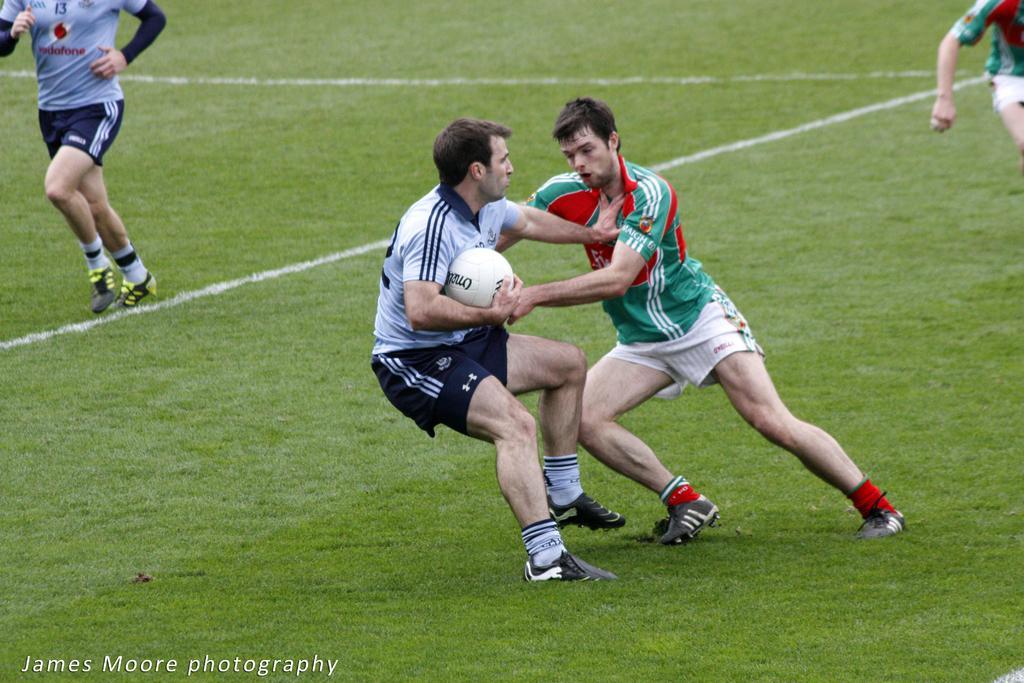How would you summarize this image in a sentence or two? In this picture we can see there are four people playing a game. A man is holding a ball and on the image there is a watermark. 